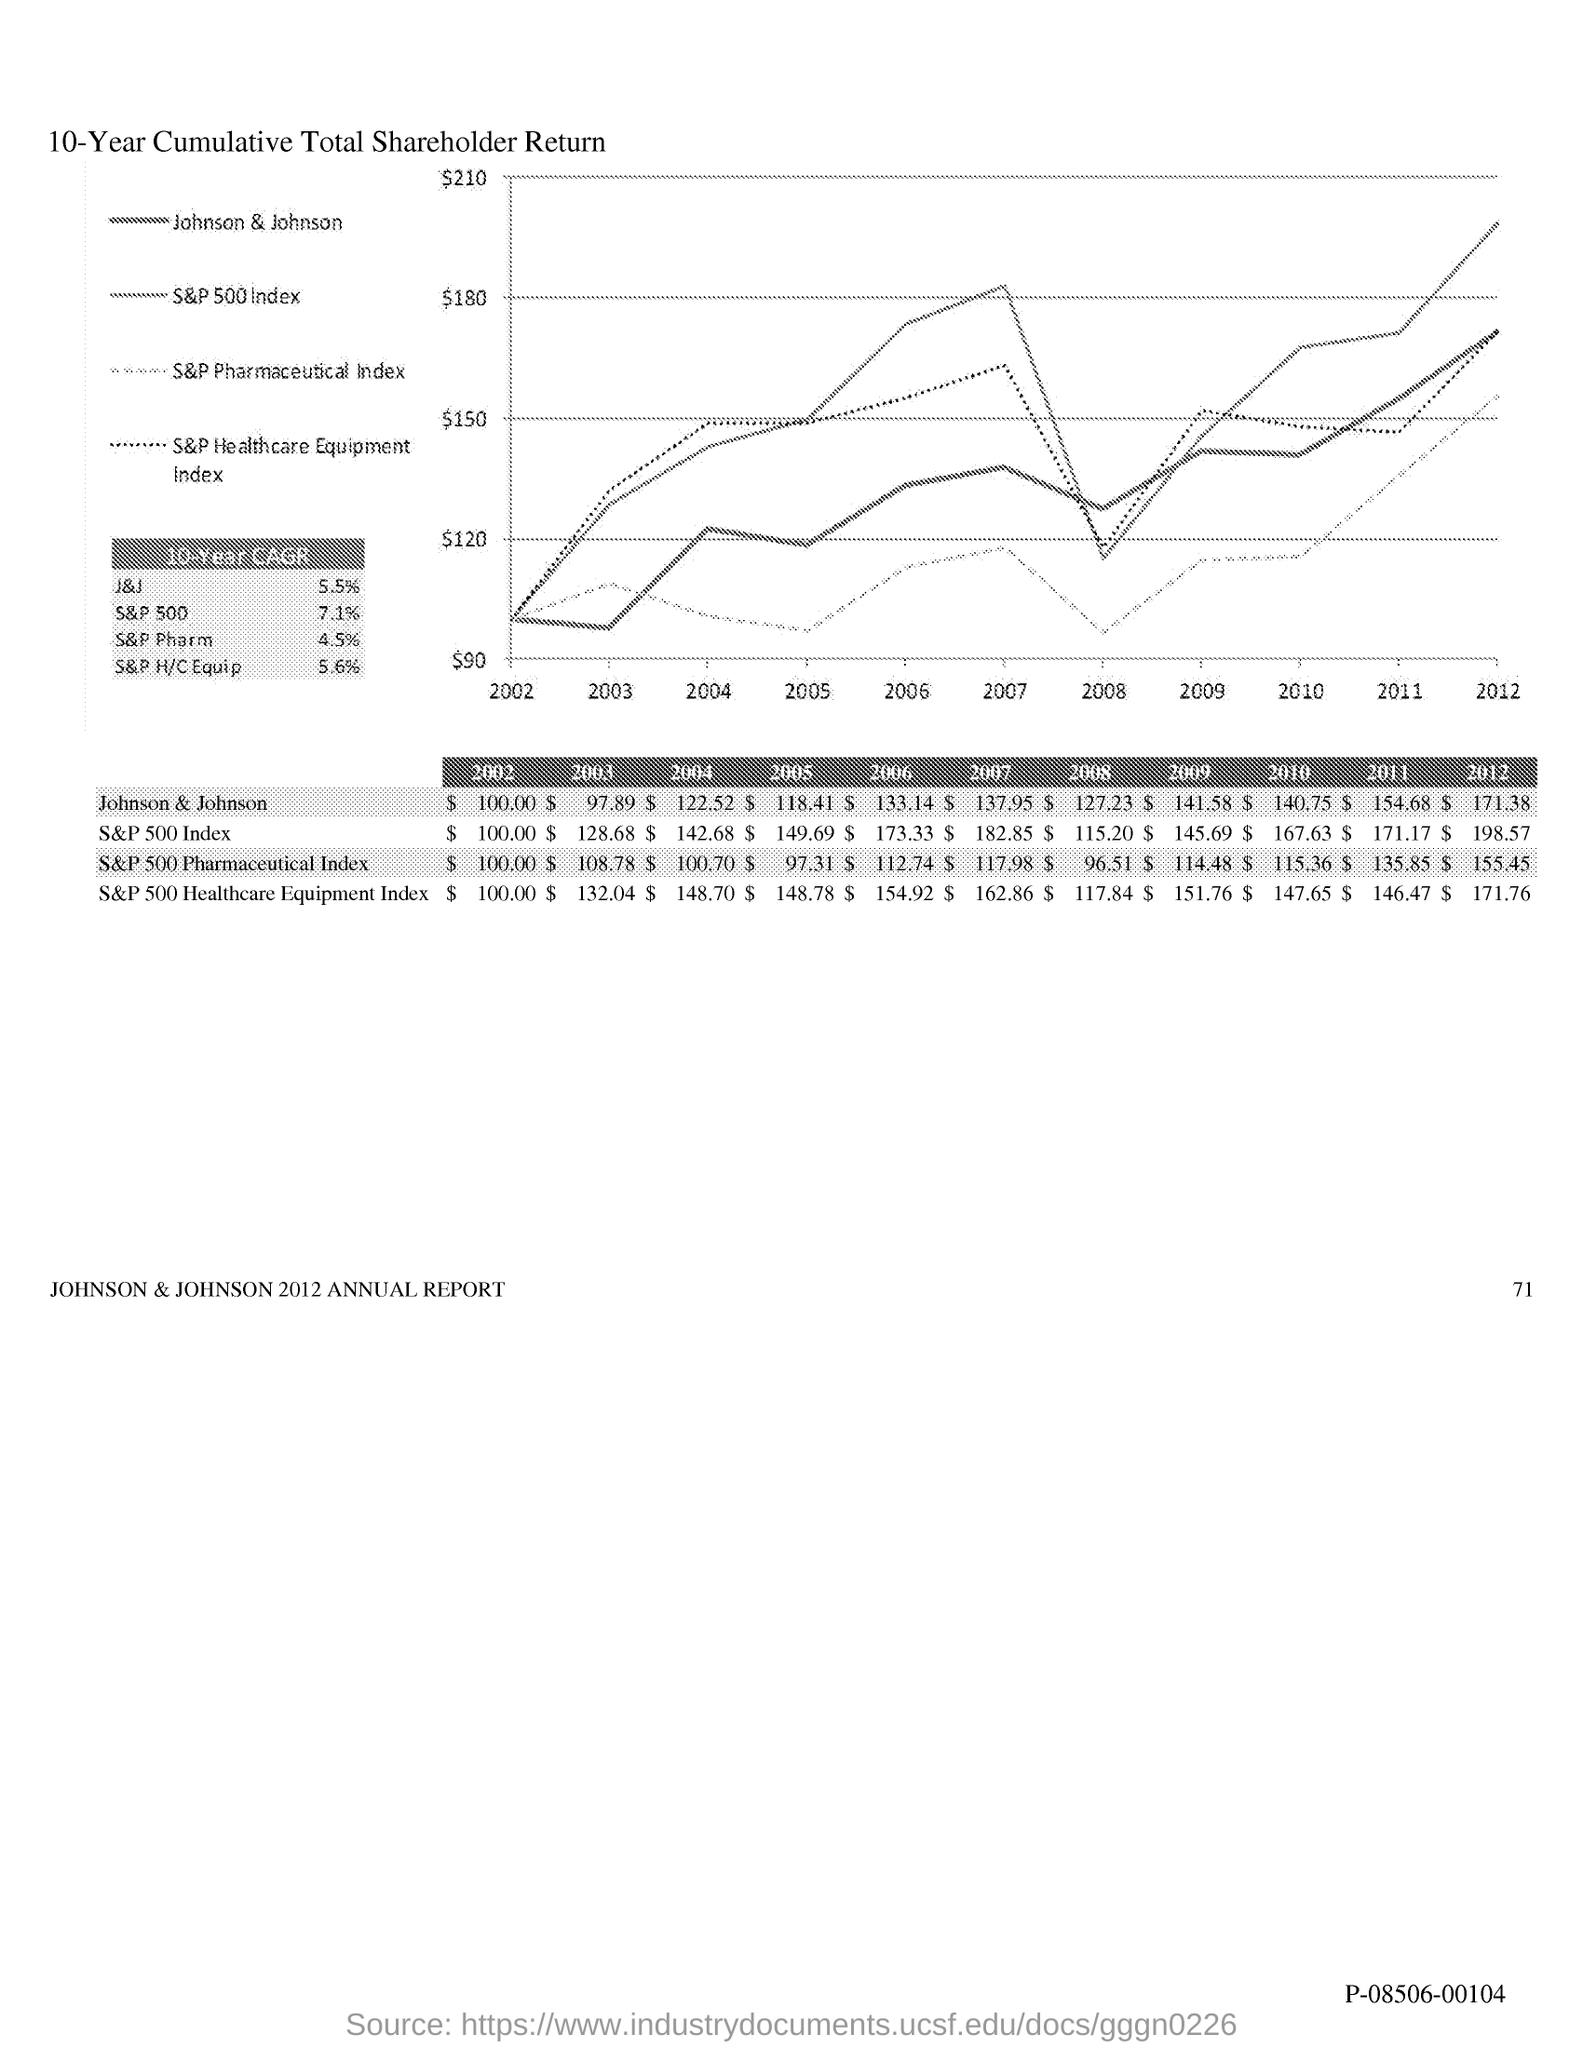What is the value of johnson & johnson in 2002 ?
Keep it short and to the point. $ 100.00. What is the value of johnson & johnson in 2003?
Ensure brevity in your answer.  $ 97.89. What is the value of johnson & johnson in 2004?
Give a very brief answer. $ 122.52. What is the value of johnson & johnson in 2005?
Ensure brevity in your answer.  $118.41. What is the value of johnson & johnson in 2007?
Keep it short and to the point. $137.95. What is the value of johnson & johnson in 2008?
Make the answer very short. $127.23. What is the value of johnson & johnson in 2009?
Your answer should be compact. $141.58. What is the value of johnson & johnson in 2010?
Make the answer very short. $140.75. What is the value of johnson & johnson in 2011?
Make the answer very short. $154.68. 